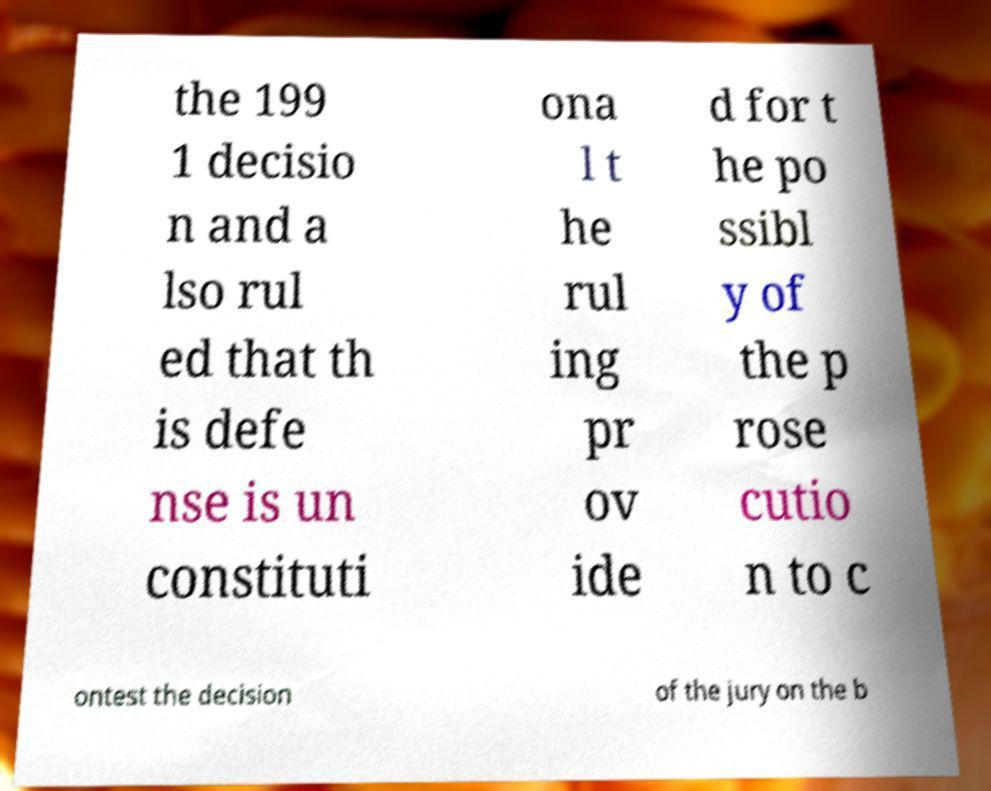What messages or text are displayed in this image? I need them in a readable, typed format. the 199 1 decisio n and a lso rul ed that th is defe nse is un constituti ona l t he rul ing pr ov ide d for t he po ssibl y of the p rose cutio n to c ontest the decision of the jury on the b 